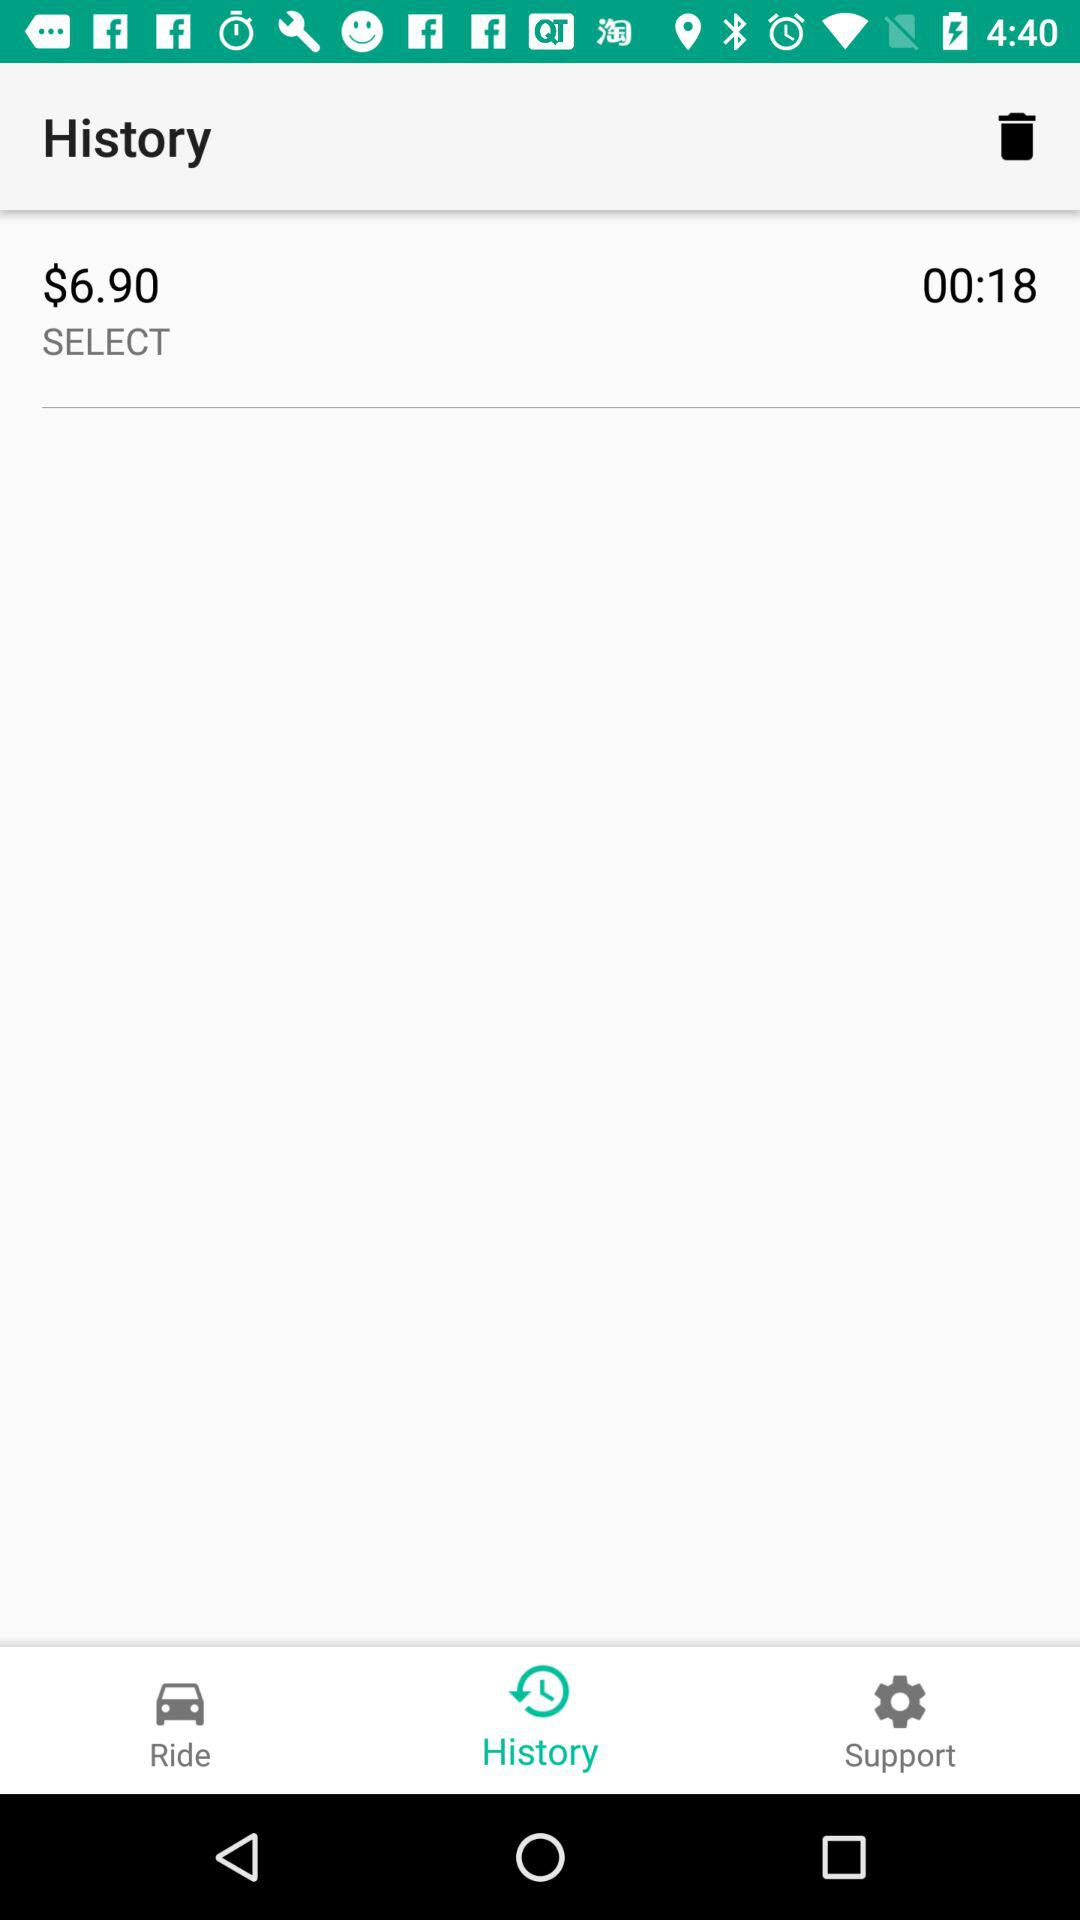What is the price in history? The price is $6.90. 